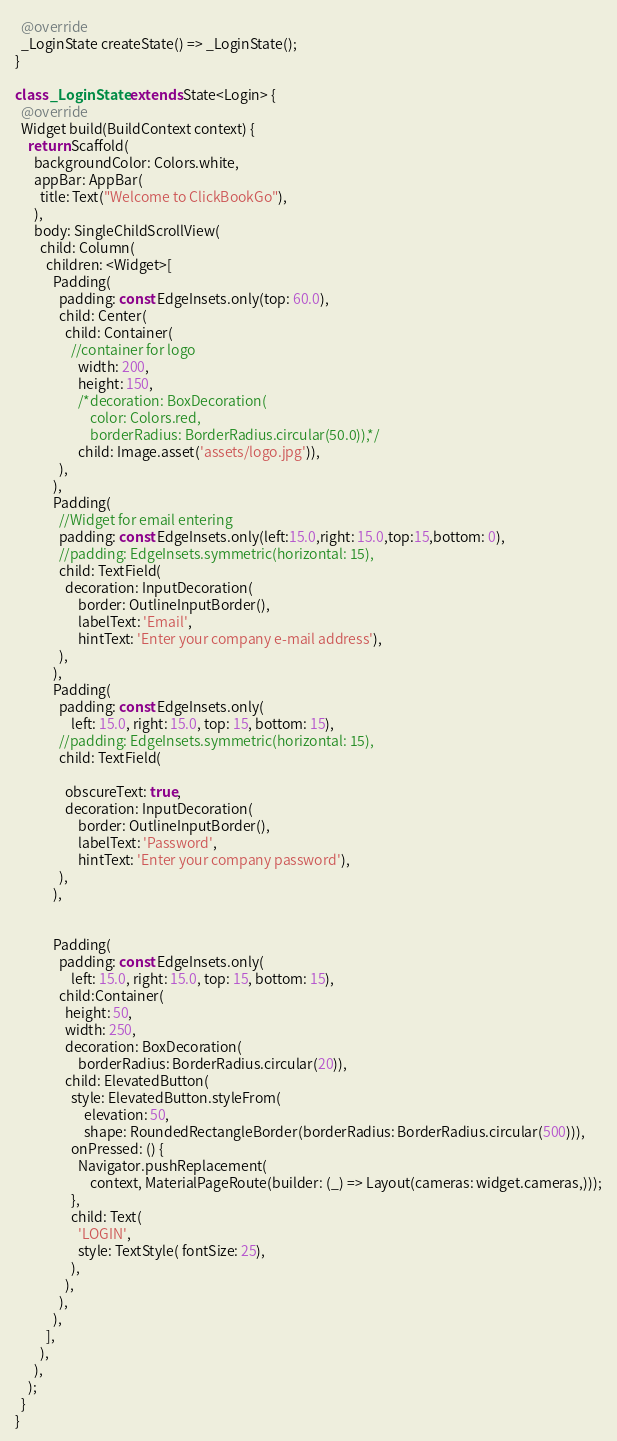<code> <loc_0><loc_0><loc_500><loc_500><_Dart_>  @override
  _LoginState createState() => _LoginState();
}

class _LoginState extends State<Login> {
  @override
  Widget build(BuildContext context) {
    return Scaffold(
      backgroundColor: Colors.white,
      appBar: AppBar(
        title: Text("Welcome to ClickBookGo"),
      ),
      body: SingleChildScrollView(
        child: Column(
          children: <Widget>[
            Padding(
              padding: const EdgeInsets.only(top: 60.0),
              child: Center(
                child: Container(
                  //container for logo
                    width: 200,
                    height: 150,
                    /*decoration: BoxDecoration(
                        color: Colors.red,
                        borderRadius: BorderRadius.circular(50.0)),*/
                    child: Image.asset('assets/logo.jpg')),
              ),
            ),
            Padding(
              //Widget for email entering
              padding: const EdgeInsets.only(left:15.0,right: 15.0,top:15,bottom: 0),
              //padding: EdgeInsets.symmetric(horizontal: 15),
              child: TextField(
                decoration: InputDecoration(
                    border: OutlineInputBorder(),
                    labelText: 'Email',
                    hintText: 'Enter your company e-mail address'),
              ),
            ),
            Padding(
              padding: const EdgeInsets.only(
                  left: 15.0, right: 15.0, top: 15, bottom: 15),
              //padding: EdgeInsets.symmetric(horizontal: 15),
              child: TextField(

                obscureText: true,
                decoration: InputDecoration(
                    border: OutlineInputBorder(),
                    labelText: 'Password',
                    hintText: 'Enter your company password'),
              ),
            ),


            Padding(
              padding: const EdgeInsets.only(
                  left: 15.0, right: 15.0, top: 15, bottom: 15),
              child:Container(
                height: 50,
                width: 250,
                decoration: BoxDecoration(
                    borderRadius: BorderRadius.circular(20)),
                child: ElevatedButton(
                  style: ElevatedButton.styleFrom(
                      elevation: 50,
                      shape: RoundedRectangleBorder(borderRadius: BorderRadius.circular(500))),
                  onPressed: () {
                    Navigator.pushReplacement(
                        context, MaterialPageRoute(builder: (_) => Layout(cameras: widget.cameras,)));
                  },
                  child: Text(
                    'LOGIN',
                    style: TextStyle( fontSize: 25),
                  ),
                ),
              ),
            ),
          ],
        ),
      ),
    );
  }
}</code> 